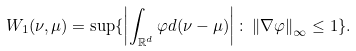Convert formula to latex. <formula><loc_0><loc_0><loc_500><loc_500>W _ { 1 } ( \nu , \mu ) = \sup \{ \left | \int _ { \mathbb { R } ^ { d } } \varphi d ( \nu - \mu ) \right | \colon \left \| \nabla \varphi \right \| _ { \infty } \leq 1 \} .</formula> 